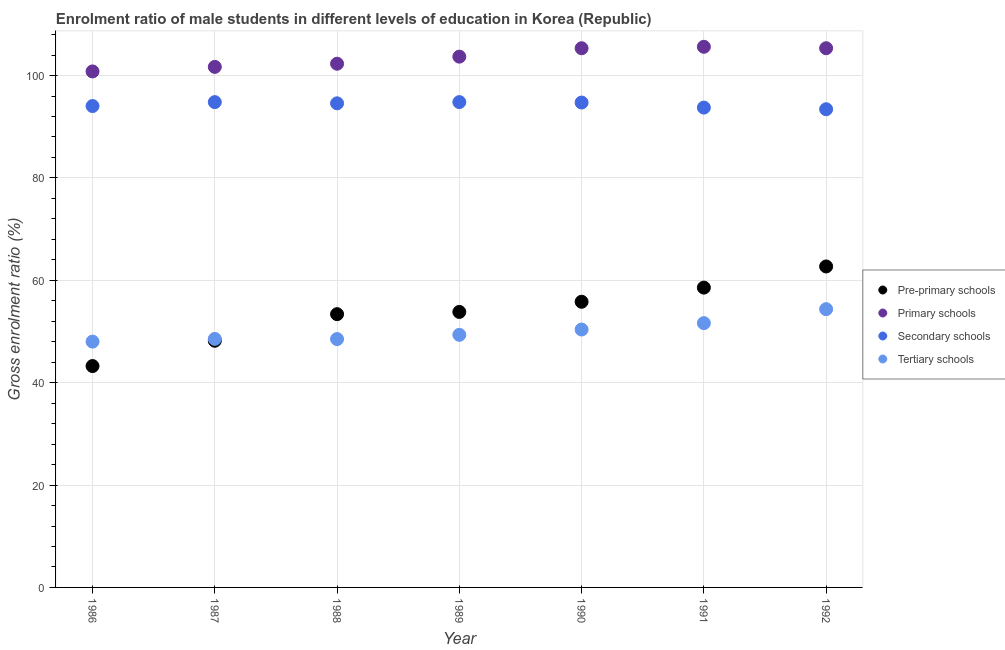How many different coloured dotlines are there?
Give a very brief answer. 4. What is the gross enrolment ratio(female) in tertiary schools in 1988?
Give a very brief answer. 48.52. Across all years, what is the maximum gross enrolment ratio(female) in pre-primary schools?
Your response must be concise. 62.71. Across all years, what is the minimum gross enrolment ratio(female) in secondary schools?
Ensure brevity in your answer.  93.42. In which year was the gross enrolment ratio(female) in tertiary schools maximum?
Offer a very short reply. 1992. What is the total gross enrolment ratio(female) in primary schools in the graph?
Your response must be concise. 724.82. What is the difference between the gross enrolment ratio(female) in tertiary schools in 1986 and that in 1992?
Your answer should be very brief. -6.34. What is the difference between the gross enrolment ratio(female) in pre-primary schools in 1990 and the gross enrolment ratio(female) in tertiary schools in 1992?
Provide a succinct answer. 1.45. What is the average gross enrolment ratio(female) in primary schools per year?
Make the answer very short. 103.55. In the year 1987, what is the difference between the gross enrolment ratio(female) in primary schools and gross enrolment ratio(female) in tertiary schools?
Keep it short and to the point. 53.14. What is the ratio of the gross enrolment ratio(female) in tertiary schools in 1988 to that in 1989?
Your answer should be very brief. 0.98. Is the gross enrolment ratio(female) in secondary schools in 1987 less than that in 1990?
Offer a terse response. No. Is the difference between the gross enrolment ratio(female) in secondary schools in 1988 and 1992 greater than the difference between the gross enrolment ratio(female) in pre-primary schools in 1988 and 1992?
Ensure brevity in your answer.  Yes. What is the difference between the highest and the second highest gross enrolment ratio(female) in pre-primary schools?
Offer a terse response. 4.13. What is the difference between the highest and the lowest gross enrolment ratio(female) in secondary schools?
Offer a terse response. 1.4. Is the sum of the gross enrolment ratio(female) in primary schools in 1986 and 1988 greater than the maximum gross enrolment ratio(female) in secondary schools across all years?
Offer a terse response. Yes. Is it the case that in every year, the sum of the gross enrolment ratio(female) in pre-primary schools and gross enrolment ratio(female) in primary schools is greater than the gross enrolment ratio(female) in secondary schools?
Offer a very short reply. Yes. Does the gross enrolment ratio(female) in pre-primary schools monotonically increase over the years?
Keep it short and to the point. Yes. Is the gross enrolment ratio(female) in primary schools strictly greater than the gross enrolment ratio(female) in pre-primary schools over the years?
Make the answer very short. Yes. Is the gross enrolment ratio(female) in primary schools strictly less than the gross enrolment ratio(female) in tertiary schools over the years?
Make the answer very short. No. What is the difference between two consecutive major ticks on the Y-axis?
Give a very brief answer. 20. Are the values on the major ticks of Y-axis written in scientific E-notation?
Provide a succinct answer. No. Does the graph contain grids?
Offer a terse response. Yes. Where does the legend appear in the graph?
Ensure brevity in your answer.  Center right. What is the title of the graph?
Your answer should be very brief. Enrolment ratio of male students in different levels of education in Korea (Republic). What is the label or title of the X-axis?
Your answer should be very brief. Year. What is the label or title of the Y-axis?
Offer a very short reply. Gross enrolment ratio (%). What is the Gross enrolment ratio (%) in Pre-primary schools in 1986?
Keep it short and to the point. 43.25. What is the Gross enrolment ratio (%) in Primary schools in 1986?
Provide a short and direct response. 100.81. What is the Gross enrolment ratio (%) in Secondary schools in 1986?
Your answer should be compact. 94.04. What is the Gross enrolment ratio (%) in Tertiary schools in 1986?
Your response must be concise. 48.02. What is the Gross enrolment ratio (%) in Pre-primary schools in 1987?
Your response must be concise. 48.19. What is the Gross enrolment ratio (%) of Primary schools in 1987?
Give a very brief answer. 101.69. What is the Gross enrolment ratio (%) in Secondary schools in 1987?
Give a very brief answer. 94.81. What is the Gross enrolment ratio (%) of Tertiary schools in 1987?
Offer a very short reply. 48.55. What is the Gross enrolment ratio (%) of Pre-primary schools in 1988?
Make the answer very short. 53.39. What is the Gross enrolment ratio (%) in Primary schools in 1988?
Provide a short and direct response. 102.32. What is the Gross enrolment ratio (%) of Secondary schools in 1988?
Offer a terse response. 94.58. What is the Gross enrolment ratio (%) in Tertiary schools in 1988?
Offer a very short reply. 48.52. What is the Gross enrolment ratio (%) of Pre-primary schools in 1989?
Your answer should be very brief. 53.82. What is the Gross enrolment ratio (%) in Primary schools in 1989?
Keep it short and to the point. 103.7. What is the Gross enrolment ratio (%) of Secondary schools in 1989?
Provide a short and direct response. 94.82. What is the Gross enrolment ratio (%) of Tertiary schools in 1989?
Provide a succinct answer. 49.35. What is the Gross enrolment ratio (%) of Pre-primary schools in 1990?
Your response must be concise. 55.81. What is the Gross enrolment ratio (%) in Primary schools in 1990?
Provide a succinct answer. 105.34. What is the Gross enrolment ratio (%) of Secondary schools in 1990?
Offer a very short reply. 94.73. What is the Gross enrolment ratio (%) of Tertiary schools in 1990?
Keep it short and to the point. 50.39. What is the Gross enrolment ratio (%) in Pre-primary schools in 1991?
Keep it short and to the point. 58.58. What is the Gross enrolment ratio (%) in Primary schools in 1991?
Keep it short and to the point. 105.62. What is the Gross enrolment ratio (%) in Secondary schools in 1991?
Provide a succinct answer. 93.74. What is the Gross enrolment ratio (%) of Tertiary schools in 1991?
Your answer should be compact. 51.63. What is the Gross enrolment ratio (%) of Pre-primary schools in 1992?
Give a very brief answer. 62.71. What is the Gross enrolment ratio (%) of Primary schools in 1992?
Ensure brevity in your answer.  105.34. What is the Gross enrolment ratio (%) in Secondary schools in 1992?
Provide a short and direct response. 93.42. What is the Gross enrolment ratio (%) of Tertiary schools in 1992?
Give a very brief answer. 54.36. Across all years, what is the maximum Gross enrolment ratio (%) in Pre-primary schools?
Your answer should be compact. 62.71. Across all years, what is the maximum Gross enrolment ratio (%) of Primary schools?
Ensure brevity in your answer.  105.62. Across all years, what is the maximum Gross enrolment ratio (%) of Secondary schools?
Offer a terse response. 94.82. Across all years, what is the maximum Gross enrolment ratio (%) in Tertiary schools?
Your response must be concise. 54.36. Across all years, what is the minimum Gross enrolment ratio (%) in Pre-primary schools?
Your answer should be very brief. 43.25. Across all years, what is the minimum Gross enrolment ratio (%) of Primary schools?
Ensure brevity in your answer.  100.81. Across all years, what is the minimum Gross enrolment ratio (%) of Secondary schools?
Your answer should be very brief. 93.42. Across all years, what is the minimum Gross enrolment ratio (%) in Tertiary schools?
Your answer should be very brief. 48.02. What is the total Gross enrolment ratio (%) in Pre-primary schools in the graph?
Provide a short and direct response. 375.74. What is the total Gross enrolment ratio (%) in Primary schools in the graph?
Offer a very short reply. 724.82. What is the total Gross enrolment ratio (%) in Secondary schools in the graph?
Offer a very short reply. 660.15. What is the total Gross enrolment ratio (%) of Tertiary schools in the graph?
Offer a terse response. 350.82. What is the difference between the Gross enrolment ratio (%) of Pre-primary schools in 1986 and that in 1987?
Your answer should be very brief. -4.95. What is the difference between the Gross enrolment ratio (%) of Primary schools in 1986 and that in 1987?
Your answer should be compact. -0.89. What is the difference between the Gross enrolment ratio (%) in Secondary schools in 1986 and that in 1987?
Provide a short and direct response. -0.77. What is the difference between the Gross enrolment ratio (%) in Tertiary schools in 1986 and that in 1987?
Your answer should be compact. -0.53. What is the difference between the Gross enrolment ratio (%) of Pre-primary schools in 1986 and that in 1988?
Your response must be concise. -10.14. What is the difference between the Gross enrolment ratio (%) of Primary schools in 1986 and that in 1988?
Keep it short and to the point. -1.51. What is the difference between the Gross enrolment ratio (%) in Secondary schools in 1986 and that in 1988?
Provide a short and direct response. -0.53. What is the difference between the Gross enrolment ratio (%) in Tertiary schools in 1986 and that in 1988?
Provide a short and direct response. -0.5. What is the difference between the Gross enrolment ratio (%) of Pre-primary schools in 1986 and that in 1989?
Ensure brevity in your answer.  -10.58. What is the difference between the Gross enrolment ratio (%) in Primary schools in 1986 and that in 1989?
Provide a succinct answer. -2.89. What is the difference between the Gross enrolment ratio (%) in Secondary schools in 1986 and that in 1989?
Provide a short and direct response. -0.77. What is the difference between the Gross enrolment ratio (%) of Tertiary schools in 1986 and that in 1989?
Provide a short and direct response. -1.33. What is the difference between the Gross enrolment ratio (%) of Pre-primary schools in 1986 and that in 1990?
Your answer should be compact. -12.56. What is the difference between the Gross enrolment ratio (%) of Primary schools in 1986 and that in 1990?
Your answer should be compact. -4.53. What is the difference between the Gross enrolment ratio (%) in Secondary schools in 1986 and that in 1990?
Give a very brief answer. -0.69. What is the difference between the Gross enrolment ratio (%) in Tertiary schools in 1986 and that in 1990?
Offer a very short reply. -2.37. What is the difference between the Gross enrolment ratio (%) in Pre-primary schools in 1986 and that in 1991?
Keep it short and to the point. -15.33. What is the difference between the Gross enrolment ratio (%) of Primary schools in 1986 and that in 1991?
Your answer should be compact. -4.81. What is the difference between the Gross enrolment ratio (%) of Secondary schools in 1986 and that in 1991?
Ensure brevity in your answer.  0.3. What is the difference between the Gross enrolment ratio (%) of Tertiary schools in 1986 and that in 1991?
Your answer should be compact. -3.61. What is the difference between the Gross enrolment ratio (%) in Pre-primary schools in 1986 and that in 1992?
Ensure brevity in your answer.  -19.46. What is the difference between the Gross enrolment ratio (%) in Primary schools in 1986 and that in 1992?
Keep it short and to the point. -4.53. What is the difference between the Gross enrolment ratio (%) in Secondary schools in 1986 and that in 1992?
Offer a very short reply. 0.62. What is the difference between the Gross enrolment ratio (%) of Tertiary schools in 1986 and that in 1992?
Your answer should be very brief. -6.34. What is the difference between the Gross enrolment ratio (%) in Pre-primary schools in 1987 and that in 1988?
Your answer should be compact. -5.19. What is the difference between the Gross enrolment ratio (%) of Primary schools in 1987 and that in 1988?
Keep it short and to the point. -0.62. What is the difference between the Gross enrolment ratio (%) of Secondary schools in 1987 and that in 1988?
Provide a short and direct response. 0.24. What is the difference between the Gross enrolment ratio (%) of Tertiary schools in 1987 and that in 1988?
Give a very brief answer. 0.03. What is the difference between the Gross enrolment ratio (%) in Pre-primary schools in 1987 and that in 1989?
Give a very brief answer. -5.63. What is the difference between the Gross enrolment ratio (%) in Primary schools in 1987 and that in 1989?
Offer a very short reply. -2. What is the difference between the Gross enrolment ratio (%) in Secondary schools in 1987 and that in 1989?
Your answer should be very brief. -0. What is the difference between the Gross enrolment ratio (%) in Tertiary schools in 1987 and that in 1989?
Your answer should be compact. -0.8. What is the difference between the Gross enrolment ratio (%) of Pre-primary schools in 1987 and that in 1990?
Your answer should be compact. -7.61. What is the difference between the Gross enrolment ratio (%) of Primary schools in 1987 and that in 1990?
Keep it short and to the point. -3.64. What is the difference between the Gross enrolment ratio (%) of Secondary schools in 1987 and that in 1990?
Your answer should be compact. 0.08. What is the difference between the Gross enrolment ratio (%) of Tertiary schools in 1987 and that in 1990?
Keep it short and to the point. -1.83. What is the difference between the Gross enrolment ratio (%) of Pre-primary schools in 1987 and that in 1991?
Provide a short and direct response. -10.38. What is the difference between the Gross enrolment ratio (%) of Primary schools in 1987 and that in 1991?
Ensure brevity in your answer.  -3.93. What is the difference between the Gross enrolment ratio (%) of Secondary schools in 1987 and that in 1991?
Keep it short and to the point. 1.07. What is the difference between the Gross enrolment ratio (%) in Tertiary schools in 1987 and that in 1991?
Provide a succinct answer. -3.08. What is the difference between the Gross enrolment ratio (%) in Pre-primary schools in 1987 and that in 1992?
Make the answer very short. -14.51. What is the difference between the Gross enrolment ratio (%) of Primary schools in 1987 and that in 1992?
Give a very brief answer. -3.65. What is the difference between the Gross enrolment ratio (%) of Secondary schools in 1987 and that in 1992?
Provide a succinct answer. 1.39. What is the difference between the Gross enrolment ratio (%) in Tertiary schools in 1987 and that in 1992?
Ensure brevity in your answer.  -5.81. What is the difference between the Gross enrolment ratio (%) of Pre-primary schools in 1988 and that in 1989?
Your response must be concise. -0.44. What is the difference between the Gross enrolment ratio (%) of Primary schools in 1988 and that in 1989?
Give a very brief answer. -1.38. What is the difference between the Gross enrolment ratio (%) in Secondary schools in 1988 and that in 1989?
Provide a short and direct response. -0.24. What is the difference between the Gross enrolment ratio (%) in Tertiary schools in 1988 and that in 1989?
Your response must be concise. -0.83. What is the difference between the Gross enrolment ratio (%) of Pre-primary schools in 1988 and that in 1990?
Provide a succinct answer. -2.42. What is the difference between the Gross enrolment ratio (%) in Primary schools in 1988 and that in 1990?
Give a very brief answer. -3.02. What is the difference between the Gross enrolment ratio (%) of Secondary schools in 1988 and that in 1990?
Make the answer very short. -0.16. What is the difference between the Gross enrolment ratio (%) of Tertiary schools in 1988 and that in 1990?
Ensure brevity in your answer.  -1.87. What is the difference between the Gross enrolment ratio (%) in Pre-primary schools in 1988 and that in 1991?
Offer a very short reply. -5.19. What is the difference between the Gross enrolment ratio (%) in Primary schools in 1988 and that in 1991?
Provide a succinct answer. -3.31. What is the difference between the Gross enrolment ratio (%) of Secondary schools in 1988 and that in 1991?
Provide a short and direct response. 0.83. What is the difference between the Gross enrolment ratio (%) in Tertiary schools in 1988 and that in 1991?
Your answer should be very brief. -3.12. What is the difference between the Gross enrolment ratio (%) of Pre-primary schools in 1988 and that in 1992?
Your answer should be compact. -9.32. What is the difference between the Gross enrolment ratio (%) in Primary schools in 1988 and that in 1992?
Your answer should be compact. -3.03. What is the difference between the Gross enrolment ratio (%) of Secondary schools in 1988 and that in 1992?
Ensure brevity in your answer.  1.15. What is the difference between the Gross enrolment ratio (%) of Tertiary schools in 1988 and that in 1992?
Your answer should be very brief. -5.84. What is the difference between the Gross enrolment ratio (%) of Pre-primary schools in 1989 and that in 1990?
Offer a very short reply. -1.98. What is the difference between the Gross enrolment ratio (%) of Primary schools in 1989 and that in 1990?
Your answer should be compact. -1.64. What is the difference between the Gross enrolment ratio (%) of Secondary schools in 1989 and that in 1990?
Your response must be concise. 0.08. What is the difference between the Gross enrolment ratio (%) of Tertiary schools in 1989 and that in 1990?
Make the answer very short. -1.04. What is the difference between the Gross enrolment ratio (%) in Pre-primary schools in 1989 and that in 1991?
Provide a short and direct response. -4.75. What is the difference between the Gross enrolment ratio (%) of Primary schools in 1989 and that in 1991?
Offer a terse response. -1.93. What is the difference between the Gross enrolment ratio (%) of Secondary schools in 1989 and that in 1991?
Give a very brief answer. 1.07. What is the difference between the Gross enrolment ratio (%) in Tertiary schools in 1989 and that in 1991?
Offer a very short reply. -2.29. What is the difference between the Gross enrolment ratio (%) in Pre-primary schools in 1989 and that in 1992?
Provide a short and direct response. -8.88. What is the difference between the Gross enrolment ratio (%) of Primary schools in 1989 and that in 1992?
Your answer should be compact. -1.65. What is the difference between the Gross enrolment ratio (%) of Secondary schools in 1989 and that in 1992?
Your answer should be compact. 1.4. What is the difference between the Gross enrolment ratio (%) in Tertiary schools in 1989 and that in 1992?
Provide a succinct answer. -5.01. What is the difference between the Gross enrolment ratio (%) in Pre-primary schools in 1990 and that in 1991?
Your answer should be compact. -2.77. What is the difference between the Gross enrolment ratio (%) in Primary schools in 1990 and that in 1991?
Ensure brevity in your answer.  -0.28. What is the difference between the Gross enrolment ratio (%) of Secondary schools in 1990 and that in 1991?
Your answer should be compact. 0.99. What is the difference between the Gross enrolment ratio (%) in Tertiary schools in 1990 and that in 1991?
Give a very brief answer. -1.25. What is the difference between the Gross enrolment ratio (%) in Pre-primary schools in 1990 and that in 1992?
Your answer should be compact. -6.9. What is the difference between the Gross enrolment ratio (%) in Primary schools in 1990 and that in 1992?
Your answer should be compact. -0. What is the difference between the Gross enrolment ratio (%) in Secondary schools in 1990 and that in 1992?
Your answer should be very brief. 1.31. What is the difference between the Gross enrolment ratio (%) of Tertiary schools in 1990 and that in 1992?
Your answer should be very brief. -3.98. What is the difference between the Gross enrolment ratio (%) in Pre-primary schools in 1991 and that in 1992?
Your answer should be very brief. -4.13. What is the difference between the Gross enrolment ratio (%) of Primary schools in 1991 and that in 1992?
Ensure brevity in your answer.  0.28. What is the difference between the Gross enrolment ratio (%) in Secondary schools in 1991 and that in 1992?
Make the answer very short. 0.32. What is the difference between the Gross enrolment ratio (%) in Tertiary schools in 1991 and that in 1992?
Your answer should be very brief. -2.73. What is the difference between the Gross enrolment ratio (%) in Pre-primary schools in 1986 and the Gross enrolment ratio (%) in Primary schools in 1987?
Your response must be concise. -58.45. What is the difference between the Gross enrolment ratio (%) in Pre-primary schools in 1986 and the Gross enrolment ratio (%) in Secondary schools in 1987?
Your answer should be very brief. -51.57. What is the difference between the Gross enrolment ratio (%) in Pre-primary schools in 1986 and the Gross enrolment ratio (%) in Tertiary schools in 1987?
Provide a short and direct response. -5.31. What is the difference between the Gross enrolment ratio (%) in Primary schools in 1986 and the Gross enrolment ratio (%) in Secondary schools in 1987?
Your answer should be very brief. 6. What is the difference between the Gross enrolment ratio (%) of Primary schools in 1986 and the Gross enrolment ratio (%) of Tertiary schools in 1987?
Offer a terse response. 52.26. What is the difference between the Gross enrolment ratio (%) of Secondary schools in 1986 and the Gross enrolment ratio (%) of Tertiary schools in 1987?
Make the answer very short. 45.49. What is the difference between the Gross enrolment ratio (%) of Pre-primary schools in 1986 and the Gross enrolment ratio (%) of Primary schools in 1988?
Offer a terse response. -59.07. What is the difference between the Gross enrolment ratio (%) of Pre-primary schools in 1986 and the Gross enrolment ratio (%) of Secondary schools in 1988?
Make the answer very short. -51.33. What is the difference between the Gross enrolment ratio (%) of Pre-primary schools in 1986 and the Gross enrolment ratio (%) of Tertiary schools in 1988?
Ensure brevity in your answer.  -5.27. What is the difference between the Gross enrolment ratio (%) in Primary schools in 1986 and the Gross enrolment ratio (%) in Secondary schools in 1988?
Give a very brief answer. 6.23. What is the difference between the Gross enrolment ratio (%) in Primary schools in 1986 and the Gross enrolment ratio (%) in Tertiary schools in 1988?
Provide a succinct answer. 52.29. What is the difference between the Gross enrolment ratio (%) in Secondary schools in 1986 and the Gross enrolment ratio (%) in Tertiary schools in 1988?
Make the answer very short. 45.53. What is the difference between the Gross enrolment ratio (%) of Pre-primary schools in 1986 and the Gross enrolment ratio (%) of Primary schools in 1989?
Your response must be concise. -60.45. What is the difference between the Gross enrolment ratio (%) of Pre-primary schools in 1986 and the Gross enrolment ratio (%) of Secondary schools in 1989?
Provide a succinct answer. -51.57. What is the difference between the Gross enrolment ratio (%) in Pre-primary schools in 1986 and the Gross enrolment ratio (%) in Tertiary schools in 1989?
Provide a succinct answer. -6.1. What is the difference between the Gross enrolment ratio (%) in Primary schools in 1986 and the Gross enrolment ratio (%) in Secondary schools in 1989?
Your answer should be very brief. 5.99. What is the difference between the Gross enrolment ratio (%) in Primary schools in 1986 and the Gross enrolment ratio (%) in Tertiary schools in 1989?
Provide a short and direct response. 51.46. What is the difference between the Gross enrolment ratio (%) of Secondary schools in 1986 and the Gross enrolment ratio (%) of Tertiary schools in 1989?
Offer a terse response. 44.7. What is the difference between the Gross enrolment ratio (%) in Pre-primary schools in 1986 and the Gross enrolment ratio (%) in Primary schools in 1990?
Provide a succinct answer. -62.09. What is the difference between the Gross enrolment ratio (%) in Pre-primary schools in 1986 and the Gross enrolment ratio (%) in Secondary schools in 1990?
Your response must be concise. -51.48. What is the difference between the Gross enrolment ratio (%) of Pre-primary schools in 1986 and the Gross enrolment ratio (%) of Tertiary schools in 1990?
Your answer should be compact. -7.14. What is the difference between the Gross enrolment ratio (%) of Primary schools in 1986 and the Gross enrolment ratio (%) of Secondary schools in 1990?
Keep it short and to the point. 6.08. What is the difference between the Gross enrolment ratio (%) in Primary schools in 1986 and the Gross enrolment ratio (%) in Tertiary schools in 1990?
Offer a terse response. 50.42. What is the difference between the Gross enrolment ratio (%) of Secondary schools in 1986 and the Gross enrolment ratio (%) of Tertiary schools in 1990?
Keep it short and to the point. 43.66. What is the difference between the Gross enrolment ratio (%) of Pre-primary schools in 1986 and the Gross enrolment ratio (%) of Primary schools in 1991?
Offer a terse response. -62.38. What is the difference between the Gross enrolment ratio (%) of Pre-primary schools in 1986 and the Gross enrolment ratio (%) of Secondary schools in 1991?
Give a very brief answer. -50.5. What is the difference between the Gross enrolment ratio (%) in Pre-primary schools in 1986 and the Gross enrolment ratio (%) in Tertiary schools in 1991?
Your response must be concise. -8.39. What is the difference between the Gross enrolment ratio (%) in Primary schools in 1986 and the Gross enrolment ratio (%) in Secondary schools in 1991?
Give a very brief answer. 7.06. What is the difference between the Gross enrolment ratio (%) in Primary schools in 1986 and the Gross enrolment ratio (%) in Tertiary schools in 1991?
Provide a short and direct response. 49.18. What is the difference between the Gross enrolment ratio (%) in Secondary schools in 1986 and the Gross enrolment ratio (%) in Tertiary schools in 1991?
Provide a short and direct response. 42.41. What is the difference between the Gross enrolment ratio (%) of Pre-primary schools in 1986 and the Gross enrolment ratio (%) of Primary schools in 1992?
Your answer should be very brief. -62.1. What is the difference between the Gross enrolment ratio (%) in Pre-primary schools in 1986 and the Gross enrolment ratio (%) in Secondary schools in 1992?
Provide a succinct answer. -50.17. What is the difference between the Gross enrolment ratio (%) of Pre-primary schools in 1986 and the Gross enrolment ratio (%) of Tertiary schools in 1992?
Your answer should be very brief. -11.12. What is the difference between the Gross enrolment ratio (%) in Primary schools in 1986 and the Gross enrolment ratio (%) in Secondary schools in 1992?
Ensure brevity in your answer.  7.39. What is the difference between the Gross enrolment ratio (%) of Primary schools in 1986 and the Gross enrolment ratio (%) of Tertiary schools in 1992?
Your answer should be very brief. 46.45. What is the difference between the Gross enrolment ratio (%) in Secondary schools in 1986 and the Gross enrolment ratio (%) in Tertiary schools in 1992?
Offer a terse response. 39.68. What is the difference between the Gross enrolment ratio (%) in Pre-primary schools in 1987 and the Gross enrolment ratio (%) in Primary schools in 1988?
Your response must be concise. -54.12. What is the difference between the Gross enrolment ratio (%) of Pre-primary schools in 1987 and the Gross enrolment ratio (%) of Secondary schools in 1988?
Offer a terse response. -46.38. What is the difference between the Gross enrolment ratio (%) of Pre-primary schools in 1987 and the Gross enrolment ratio (%) of Tertiary schools in 1988?
Your answer should be very brief. -0.32. What is the difference between the Gross enrolment ratio (%) of Primary schools in 1987 and the Gross enrolment ratio (%) of Secondary schools in 1988?
Provide a succinct answer. 7.12. What is the difference between the Gross enrolment ratio (%) in Primary schools in 1987 and the Gross enrolment ratio (%) in Tertiary schools in 1988?
Offer a very short reply. 53.18. What is the difference between the Gross enrolment ratio (%) in Secondary schools in 1987 and the Gross enrolment ratio (%) in Tertiary schools in 1988?
Make the answer very short. 46.29. What is the difference between the Gross enrolment ratio (%) in Pre-primary schools in 1987 and the Gross enrolment ratio (%) in Primary schools in 1989?
Make the answer very short. -55.5. What is the difference between the Gross enrolment ratio (%) in Pre-primary schools in 1987 and the Gross enrolment ratio (%) in Secondary schools in 1989?
Your answer should be very brief. -46.62. What is the difference between the Gross enrolment ratio (%) in Pre-primary schools in 1987 and the Gross enrolment ratio (%) in Tertiary schools in 1989?
Your answer should be very brief. -1.15. What is the difference between the Gross enrolment ratio (%) in Primary schools in 1987 and the Gross enrolment ratio (%) in Secondary schools in 1989?
Make the answer very short. 6.88. What is the difference between the Gross enrolment ratio (%) in Primary schools in 1987 and the Gross enrolment ratio (%) in Tertiary schools in 1989?
Provide a succinct answer. 52.35. What is the difference between the Gross enrolment ratio (%) of Secondary schools in 1987 and the Gross enrolment ratio (%) of Tertiary schools in 1989?
Your answer should be compact. 45.46. What is the difference between the Gross enrolment ratio (%) of Pre-primary schools in 1987 and the Gross enrolment ratio (%) of Primary schools in 1990?
Your answer should be very brief. -57.14. What is the difference between the Gross enrolment ratio (%) of Pre-primary schools in 1987 and the Gross enrolment ratio (%) of Secondary schools in 1990?
Your answer should be very brief. -46.54. What is the difference between the Gross enrolment ratio (%) of Pre-primary schools in 1987 and the Gross enrolment ratio (%) of Tertiary schools in 1990?
Ensure brevity in your answer.  -2.19. What is the difference between the Gross enrolment ratio (%) in Primary schools in 1987 and the Gross enrolment ratio (%) in Secondary schools in 1990?
Offer a terse response. 6.96. What is the difference between the Gross enrolment ratio (%) of Primary schools in 1987 and the Gross enrolment ratio (%) of Tertiary schools in 1990?
Your response must be concise. 51.31. What is the difference between the Gross enrolment ratio (%) of Secondary schools in 1987 and the Gross enrolment ratio (%) of Tertiary schools in 1990?
Offer a very short reply. 44.43. What is the difference between the Gross enrolment ratio (%) in Pre-primary schools in 1987 and the Gross enrolment ratio (%) in Primary schools in 1991?
Provide a short and direct response. -57.43. What is the difference between the Gross enrolment ratio (%) in Pre-primary schools in 1987 and the Gross enrolment ratio (%) in Secondary schools in 1991?
Give a very brief answer. -45.55. What is the difference between the Gross enrolment ratio (%) in Pre-primary schools in 1987 and the Gross enrolment ratio (%) in Tertiary schools in 1991?
Offer a terse response. -3.44. What is the difference between the Gross enrolment ratio (%) in Primary schools in 1987 and the Gross enrolment ratio (%) in Secondary schools in 1991?
Provide a succinct answer. 7.95. What is the difference between the Gross enrolment ratio (%) in Primary schools in 1987 and the Gross enrolment ratio (%) in Tertiary schools in 1991?
Provide a succinct answer. 50.06. What is the difference between the Gross enrolment ratio (%) in Secondary schools in 1987 and the Gross enrolment ratio (%) in Tertiary schools in 1991?
Your response must be concise. 43.18. What is the difference between the Gross enrolment ratio (%) of Pre-primary schools in 1987 and the Gross enrolment ratio (%) of Primary schools in 1992?
Keep it short and to the point. -57.15. What is the difference between the Gross enrolment ratio (%) in Pre-primary schools in 1987 and the Gross enrolment ratio (%) in Secondary schools in 1992?
Your response must be concise. -45.23. What is the difference between the Gross enrolment ratio (%) of Pre-primary schools in 1987 and the Gross enrolment ratio (%) of Tertiary schools in 1992?
Your answer should be very brief. -6.17. What is the difference between the Gross enrolment ratio (%) of Primary schools in 1987 and the Gross enrolment ratio (%) of Secondary schools in 1992?
Your response must be concise. 8.27. What is the difference between the Gross enrolment ratio (%) in Primary schools in 1987 and the Gross enrolment ratio (%) in Tertiary schools in 1992?
Ensure brevity in your answer.  47.33. What is the difference between the Gross enrolment ratio (%) of Secondary schools in 1987 and the Gross enrolment ratio (%) of Tertiary schools in 1992?
Give a very brief answer. 40.45. What is the difference between the Gross enrolment ratio (%) of Pre-primary schools in 1988 and the Gross enrolment ratio (%) of Primary schools in 1989?
Your response must be concise. -50.31. What is the difference between the Gross enrolment ratio (%) of Pre-primary schools in 1988 and the Gross enrolment ratio (%) of Secondary schools in 1989?
Provide a short and direct response. -41.43. What is the difference between the Gross enrolment ratio (%) of Pre-primary schools in 1988 and the Gross enrolment ratio (%) of Tertiary schools in 1989?
Provide a short and direct response. 4.04. What is the difference between the Gross enrolment ratio (%) of Primary schools in 1988 and the Gross enrolment ratio (%) of Secondary schools in 1989?
Your answer should be very brief. 7.5. What is the difference between the Gross enrolment ratio (%) of Primary schools in 1988 and the Gross enrolment ratio (%) of Tertiary schools in 1989?
Keep it short and to the point. 52.97. What is the difference between the Gross enrolment ratio (%) in Secondary schools in 1988 and the Gross enrolment ratio (%) in Tertiary schools in 1989?
Give a very brief answer. 45.23. What is the difference between the Gross enrolment ratio (%) in Pre-primary schools in 1988 and the Gross enrolment ratio (%) in Primary schools in 1990?
Offer a very short reply. -51.95. What is the difference between the Gross enrolment ratio (%) of Pre-primary schools in 1988 and the Gross enrolment ratio (%) of Secondary schools in 1990?
Provide a short and direct response. -41.35. What is the difference between the Gross enrolment ratio (%) of Pre-primary schools in 1988 and the Gross enrolment ratio (%) of Tertiary schools in 1990?
Provide a succinct answer. 3. What is the difference between the Gross enrolment ratio (%) in Primary schools in 1988 and the Gross enrolment ratio (%) in Secondary schools in 1990?
Keep it short and to the point. 7.58. What is the difference between the Gross enrolment ratio (%) of Primary schools in 1988 and the Gross enrolment ratio (%) of Tertiary schools in 1990?
Offer a very short reply. 51.93. What is the difference between the Gross enrolment ratio (%) in Secondary schools in 1988 and the Gross enrolment ratio (%) in Tertiary schools in 1990?
Your answer should be very brief. 44.19. What is the difference between the Gross enrolment ratio (%) in Pre-primary schools in 1988 and the Gross enrolment ratio (%) in Primary schools in 1991?
Your answer should be compact. -52.24. What is the difference between the Gross enrolment ratio (%) of Pre-primary schools in 1988 and the Gross enrolment ratio (%) of Secondary schools in 1991?
Provide a succinct answer. -40.36. What is the difference between the Gross enrolment ratio (%) in Pre-primary schools in 1988 and the Gross enrolment ratio (%) in Tertiary schools in 1991?
Provide a succinct answer. 1.75. What is the difference between the Gross enrolment ratio (%) in Primary schools in 1988 and the Gross enrolment ratio (%) in Secondary schools in 1991?
Make the answer very short. 8.57. What is the difference between the Gross enrolment ratio (%) of Primary schools in 1988 and the Gross enrolment ratio (%) of Tertiary schools in 1991?
Ensure brevity in your answer.  50.68. What is the difference between the Gross enrolment ratio (%) in Secondary schools in 1988 and the Gross enrolment ratio (%) in Tertiary schools in 1991?
Your response must be concise. 42.94. What is the difference between the Gross enrolment ratio (%) in Pre-primary schools in 1988 and the Gross enrolment ratio (%) in Primary schools in 1992?
Offer a very short reply. -51.96. What is the difference between the Gross enrolment ratio (%) in Pre-primary schools in 1988 and the Gross enrolment ratio (%) in Secondary schools in 1992?
Make the answer very short. -40.04. What is the difference between the Gross enrolment ratio (%) in Pre-primary schools in 1988 and the Gross enrolment ratio (%) in Tertiary schools in 1992?
Give a very brief answer. -0.98. What is the difference between the Gross enrolment ratio (%) of Primary schools in 1988 and the Gross enrolment ratio (%) of Secondary schools in 1992?
Provide a short and direct response. 8.89. What is the difference between the Gross enrolment ratio (%) in Primary schools in 1988 and the Gross enrolment ratio (%) in Tertiary schools in 1992?
Offer a terse response. 47.95. What is the difference between the Gross enrolment ratio (%) of Secondary schools in 1988 and the Gross enrolment ratio (%) of Tertiary schools in 1992?
Provide a succinct answer. 40.21. What is the difference between the Gross enrolment ratio (%) in Pre-primary schools in 1989 and the Gross enrolment ratio (%) in Primary schools in 1990?
Your answer should be very brief. -51.51. What is the difference between the Gross enrolment ratio (%) in Pre-primary schools in 1989 and the Gross enrolment ratio (%) in Secondary schools in 1990?
Offer a terse response. -40.91. What is the difference between the Gross enrolment ratio (%) in Pre-primary schools in 1989 and the Gross enrolment ratio (%) in Tertiary schools in 1990?
Give a very brief answer. 3.44. What is the difference between the Gross enrolment ratio (%) in Primary schools in 1989 and the Gross enrolment ratio (%) in Secondary schools in 1990?
Provide a succinct answer. 8.96. What is the difference between the Gross enrolment ratio (%) of Primary schools in 1989 and the Gross enrolment ratio (%) of Tertiary schools in 1990?
Ensure brevity in your answer.  53.31. What is the difference between the Gross enrolment ratio (%) in Secondary schools in 1989 and the Gross enrolment ratio (%) in Tertiary schools in 1990?
Offer a terse response. 44.43. What is the difference between the Gross enrolment ratio (%) of Pre-primary schools in 1989 and the Gross enrolment ratio (%) of Primary schools in 1991?
Keep it short and to the point. -51.8. What is the difference between the Gross enrolment ratio (%) in Pre-primary schools in 1989 and the Gross enrolment ratio (%) in Secondary schools in 1991?
Make the answer very short. -39.92. What is the difference between the Gross enrolment ratio (%) of Pre-primary schools in 1989 and the Gross enrolment ratio (%) of Tertiary schools in 1991?
Your answer should be very brief. 2.19. What is the difference between the Gross enrolment ratio (%) of Primary schools in 1989 and the Gross enrolment ratio (%) of Secondary schools in 1991?
Give a very brief answer. 9.95. What is the difference between the Gross enrolment ratio (%) of Primary schools in 1989 and the Gross enrolment ratio (%) of Tertiary schools in 1991?
Offer a very short reply. 52.06. What is the difference between the Gross enrolment ratio (%) of Secondary schools in 1989 and the Gross enrolment ratio (%) of Tertiary schools in 1991?
Your response must be concise. 43.18. What is the difference between the Gross enrolment ratio (%) of Pre-primary schools in 1989 and the Gross enrolment ratio (%) of Primary schools in 1992?
Provide a short and direct response. -51.52. What is the difference between the Gross enrolment ratio (%) of Pre-primary schools in 1989 and the Gross enrolment ratio (%) of Secondary schools in 1992?
Offer a very short reply. -39.6. What is the difference between the Gross enrolment ratio (%) in Pre-primary schools in 1989 and the Gross enrolment ratio (%) in Tertiary schools in 1992?
Give a very brief answer. -0.54. What is the difference between the Gross enrolment ratio (%) in Primary schools in 1989 and the Gross enrolment ratio (%) in Secondary schools in 1992?
Provide a succinct answer. 10.27. What is the difference between the Gross enrolment ratio (%) in Primary schools in 1989 and the Gross enrolment ratio (%) in Tertiary schools in 1992?
Provide a short and direct response. 49.33. What is the difference between the Gross enrolment ratio (%) in Secondary schools in 1989 and the Gross enrolment ratio (%) in Tertiary schools in 1992?
Give a very brief answer. 40.45. What is the difference between the Gross enrolment ratio (%) of Pre-primary schools in 1990 and the Gross enrolment ratio (%) of Primary schools in 1991?
Your answer should be compact. -49.81. What is the difference between the Gross enrolment ratio (%) of Pre-primary schools in 1990 and the Gross enrolment ratio (%) of Secondary schools in 1991?
Provide a short and direct response. -37.94. What is the difference between the Gross enrolment ratio (%) of Pre-primary schools in 1990 and the Gross enrolment ratio (%) of Tertiary schools in 1991?
Provide a short and direct response. 4.18. What is the difference between the Gross enrolment ratio (%) of Primary schools in 1990 and the Gross enrolment ratio (%) of Secondary schools in 1991?
Your response must be concise. 11.59. What is the difference between the Gross enrolment ratio (%) in Primary schools in 1990 and the Gross enrolment ratio (%) in Tertiary schools in 1991?
Provide a succinct answer. 53.7. What is the difference between the Gross enrolment ratio (%) of Secondary schools in 1990 and the Gross enrolment ratio (%) of Tertiary schools in 1991?
Give a very brief answer. 43.1. What is the difference between the Gross enrolment ratio (%) of Pre-primary schools in 1990 and the Gross enrolment ratio (%) of Primary schools in 1992?
Make the answer very short. -49.53. What is the difference between the Gross enrolment ratio (%) of Pre-primary schools in 1990 and the Gross enrolment ratio (%) of Secondary schools in 1992?
Offer a terse response. -37.61. What is the difference between the Gross enrolment ratio (%) of Pre-primary schools in 1990 and the Gross enrolment ratio (%) of Tertiary schools in 1992?
Offer a very short reply. 1.45. What is the difference between the Gross enrolment ratio (%) in Primary schools in 1990 and the Gross enrolment ratio (%) in Secondary schools in 1992?
Make the answer very short. 11.92. What is the difference between the Gross enrolment ratio (%) of Primary schools in 1990 and the Gross enrolment ratio (%) of Tertiary schools in 1992?
Provide a succinct answer. 50.98. What is the difference between the Gross enrolment ratio (%) in Secondary schools in 1990 and the Gross enrolment ratio (%) in Tertiary schools in 1992?
Your response must be concise. 40.37. What is the difference between the Gross enrolment ratio (%) in Pre-primary schools in 1991 and the Gross enrolment ratio (%) in Primary schools in 1992?
Your answer should be compact. -46.77. What is the difference between the Gross enrolment ratio (%) in Pre-primary schools in 1991 and the Gross enrolment ratio (%) in Secondary schools in 1992?
Your response must be concise. -34.85. What is the difference between the Gross enrolment ratio (%) of Pre-primary schools in 1991 and the Gross enrolment ratio (%) of Tertiary schools in 1992?
Your response must be concise. 4.21. What is the difference between the Gross enrolment ratio (%) of Primary schools in 1991 and the Gross enrolment ratio (%) of Secondary schools in 1992?
Give a very brief answer. 12.2. What is the difference between the Gross enrolment ratio (%) of Primary schools in 1991 and the Gross enrolment ratio (%) of Tertiary schools in 1992?
Provide a succinct answer. 51.26. What is the difference between the Gross enrolment ratio (%) in Secondary schools in 1991 and the Gross enrolment ratio (%) in Tertiary schools in 1992?
Offer a very short reply. 39.38. What is the average Gross enrolment ratio (%) of Pre-primary schools per year?
Your response must be concise. 53.68. What is the average Gross enrolment ratio (%) of Primary schools per year?
Give a very brief answer. 103.55. What is the average Gross enrolment ratio (%) in Secondary schools per year?
Your answer should be very brief. 94.31. What is the average Gross enrolment ratio (%) in Tertiary schools per year?
Offer a very short reply. 50.12. In the year 1986, what is the difference between the Gross enrolment ratio (%) of Pre-primary schools and Gross enrolment ratio (%) of Primary schools?
Give a very brief answer. -57.56. In the year 1986, what is the difference between the Gross enrolment ratio (%) of Pre-primary schools and Gross enrolment ratio (%) of Secondary schools?
Provide a succinct answer. -50.8. In the year 1986, what is the difference between the Gross enrolment ratio (%) in Pre-primary schools and Gross enrolment ratio (%) in Tertiary schools?
Your answer should be very brief. -4.77. In the year 1986, what is the difference between the Gross enrolment ratio (%) in Primary schools and Gross enrolment ratio (%) in Secondary schools?
Offer a very short reply. 6.76. In the year 1986, what is the difference between the Gross enrolment ratio (%) in Primary schools and Gross enrolment ratio (%) in Tertiary schools?
Keep it short and to the point. 52.79. In the year 1986, what is the difference between the Gross enrolment ratio (%) in Secondary schools and Gross enrolment ratio (%) in Tertiary schools?
Make the answer very short. 46.03. In the year 1987, what is the difference between the Gross enrolment ratio (%) in Pre-primary schools and Gross enrolment ratio (%) in Primary schools?
Offer a very short reply. -53.5. In the year 1987, what is the difference between the Gross enrolment ratio (%) in Pre-primary schools and Gross enrolment ratio (%) in Secondary schools?
Keep it short and to the point. -46.62. In the year 1987, what is the difference between the Gross enrolment ratio (%) of Pre-primary schools and Gross enrolment ratio (%) of Tertiary schools?
Give a very brief answer. -0.36. In the year 1987, what is the difference between the Gross enrolment ratio (%) of Primary schools and Gross enrolment ratio (%) of Secondary schools?
Ensure brevity in your answer.  6.88. In the year 1987, what is the difference between the Gross enrolment ratio (%) of Primary schools and Gross enrolment ratio (%) of Tertiary schools?
Keep it short and to the point. 53.14. In the year 1987, what is the difference between the Gross enrolment ratio (%) in Secondary schools and Gross enrolment ratio (%) in Tertiary schools?
Offer a terse response. 46.26. In the year 1988, what is the difference between the Gross enrolment ratio (%) of Pre-primary schools and Gross enrolment ratio (%) of Primary schools?
Offer a terse response. -48.93. In the year 1988, what is the difference between the Gross enrolment ratio (%) in Pre-primary schools and Gross enrolment ratio (%) in Secondary schools?
Offer a very short reply. -41.19. In the year 1988, what is the difference between the Gross enrolment ratio (%) in Pre-primary schools and Gross enrolment ratio (%) in Tertiary schools?
Offer a very short reply. 4.87. In the year 1988, what is the difference between the Gross enrolment ratio (%) in Primary schools and Gross enrolment ratio (%) in Secondary schools?
Your response must be concise. 7.74. In the year 1988, what is the difference between the Gross enrolment ratio (%) in Primary schools and Gross enrolment ratio (%) in Tertiary schools?
Offer a very short reply. 53.8. In the year 1988, what is the difference between the Gross enrolment ratio (%) in Secondary schools and Gross enrolment ratio (%) in Tertiary schools?
Make the answer very short. 46.06. In the year 1989, what is the difference between the Gross enrolment ratio (%) in Pre-primary schools and Gross enrolment ratio (%) in Primary schools?
Give a very brief answer. -49.87. In the year 1989, what is the difference between the Gross enrolment ratio (%) of Pre-primary schools and Gross enrolment ratio (%) of Secondary schools?
Provide a short and direct response. -40.99. In the year 1989, what is the difference between the Gross enrolment ratio (%) in Pre-primary schools and Gross enrolment ratio (%) in Tertiary schools?
Make the answer very short. 4.48. In the year 1989, what is the difference between the Gross enrolment ratio (%) in Primary schools and Gross enrolment ratio (%) in Secondary schools?
Ensure brevity in your answer.  8.88. In the year 1989, what is the difference between the Gross enrolment ratio (%) of Primary schools and Gross enrolment ratio (%) of Tertiary schools?
Offer a terse response. 54.35. In the year 1989, what is the difference between the Gross enrolment ratio (%) in Secondary schools and Gross enrolment ratio (%) in Tertiary schools?
Provide a short and direct response. 45.47. In the year 1990, what is the difference between the Gross enrolment ratio (%) of Pre-primary schools and Gross enrolment ratio (%) of Primary schools?
Offer a terse response. -49.53. In the year 1990, what is the difference between the Gross enrolment ratio (%) in Pre-primary schools and Gross enrolment ratio (%) in Secondary schools?
Keep it short and to the point. -38.92. In the year 1990, what is the difference between the Gross enrolment ratio (%) in Pre-primary schools and Gross enrolment ratio (%) in Tertiary schools?
Offer a terse response. 5.42. In the year 1990, what is the difference between the Gross enrolment ratio (%) of Primary schools and Gross enrolment ratio (%) of Secondary schools?
Your answer should be compact. 10.61. In the year 1990, what is the difference between the Gross enrolment ratio (%) of Primary schools and Gross enrolment ratio (%) of Tertiary schools?
Your answer should be very brief. 54.95. In the year 1990, what is the difference between the Gross enrolment ratio (%) in Secondary schools and Gross enrolment ratio (%) in Tertiary schools?
Make the answer very short. 44.35. In the year 1991, what is the difference between the Gross enrolment ratio (%) of Pre-primary schools and Gross enrolment ratio (%) of Primary schools?
Offer a very short reply. -47.05. In the year 1991, what is the difference between the Gross enrolment ratio (%) of Pre-primary schools and Gross enrolment ratio (%) of Secondary schools?
Your answer should be compact. -35.17. In the year 1991, what is the difference between the Gross enrolment ratio (%) of Pre-primary schools and Gross enrolment ratio (%) of Tertiary schools?
Your answer should be compact. 6.94. In the year 1991, what is the difference between the Gross enrolment ratio (%) in Primary schools and Gross enrolment ratio (%) in Secondary schools?
Ensure brevity in your answer.  11.88. In the year 1991, what is the difference between the Gross enrolment ratio (%) of Primary schools and Gross enrolment ratio (%) of Tertiary schools?
Keep it short and to the point. 53.99. In the year 1991, what is the difference between the Gross enrolment ratio (%) in Secondary schools and Gross enrolment ratio (%) in Tertiary schools?
Provide a succinct answer. 42.11. In the year 1992, what is the difference between the Gross enrolment ratio (%) in Pre-primary schools and Gross enrolment ratio (%) in Primary schools?
Give a very brief answer. -42.64. In the year 1992, what is the difference between the Gross enrolment ratio (%) in Pre-primary schools and Gross enrolment ratio (%) in Secondary schools?
Make the answer very short. -30.72. In the year 1992, what is the difference between the Gross enrolment ratio (%) of Pre-primary schools and Gross enrolment ratio (%) of Tertiary schools?
Your answer should be compact. 8.34. In the year 1992, what is the difference between the Gross enrolment ratio (%) of Primary schools and Gross enrolment ratio (%) of Secondary schools?
Provide a succinct answer. 11.92. In the year 1992, what is the difference between the Gross enrolment ratio (%) in Primary schools and Gross enrolment ratio (%) in Tertiary schools?
Give a very brief answer. 50.98. In the year 1992, what is the difference between the Gross enrolment ratio (%) of Secondary schools and Gross enrolment ratio (%) of Tertiary schools?
Provide a succinct answer. 39.06. What is the ratio of the Gross enrolment ratio (%) of Pre-primary schools in 1986 to that in 1987?
Provide a short and direct response. 0.9. What is the ratio of the Gross enrolment ratio (%) of Primary schools in 1986 to that in 1987?
Make the answer very short. 0.99. What is the ratio of the Gross enrolment ratio (%) of Pre-primary schools in 1986 to that in 1988?
Your answer should be compact. 0.81. What is the ratio of the Gross enrolment ratio (%) of Primary schools in 1986 to that in 1988?
Provide a succinct answer. 0.99. What is the ratio of the Gross enrolment ratio (%) in Tertiary schools in 1986 to that in 1988?
Your response must be concise. 0.99. What is the ratio of the Gross enrolment ratio (%) in Pre-primary schools in 1986 to that in 1989?
Your answer should be very brief. 0.8. What is the ratio of the Gross enrolment ratio (%) in Primary schools in 1986 to that in 1989?
Keep it short and to the point. 0.97. What is the ratio of the Gross enrolment ratio (%) in Tertiary schools in 1986 to that in 1989?
Give a very brief answer. 0.97. What is the ratio of the Gross enrolment ratio (%) in Pre-primary schools in 1986 to that in 1990?
Provide a succinct answer. 0.77. What is the ratio of the Gross enrolment ratio (%) in Primary schools in 1986 to that in 1990?
Give a very brief answer. 0.96. What is the ratio of the Gross enrolment ratio (%) in Tertiary schools in 1986 to that in 1990?
Your answer should be compact. 0.95. What is the ratio of the Gross enrolment ratio (%) of Pre-primary schools in 1986 to that in 1991?
Offer a very short reply. 0.74. What is the ratio of the Gross enrolment ratio (%) of Primary schools in 1986 to that in 1991?
Provide a short and direct response. 0.95. What is the ratio of the Gross enrolment ratio (%) in Tertiary schools in 1986 to that in 1991?
Offer a terse response. 0.93. What is the ratio of the Gross enrolment ratio (%) of Pre-primary schools in 1986 to that in 1992?
Provide a short and direct response. 0.69. What is the ratio of the Gross enrolment ratio (%) in Tertiary schools in 1986 to that in 1992?
Offer a terse response. 0.88. What is the ratio of the Gross enrolment ratio (%) of Pre-primary schools in 1987 to that in 1988?
Offer a very short reply. 0.9. What is the ratio of the Gross enrolment ratio (%) in Primary schools in 1987 to that in 1988?
Make the answer very short. 0.99. What is the ratio of the Gross enrolment ratio (%) of Pre-primary schools in 1987 to that in 1989?
Keep it short and to the point. 0.9. What is the ratio of the Gross enrolment ratio (%) of Primary schools in 1987 to that in 1989?
Your answer should be very brief. 0.98. What is the ratio of the Gross enrolment ratio (%) in Tertiary schools in 1987 to that in 1989?
Give a very brief answer. 0.98. What is the ratio of the Gross enrolment ratio (%) of Pre-primary schools in 1987 to that in 1990?
Your answer should be very brief. 0.86. What is the ratio of the Gross enrolment ratio (%) of Primary schools in 1987 to that in 1990?
Keep it short and to the point. 0.97. What is the ratio of the Gross enrolment ratio (%) in Secondary schools in 1987 to that in 1990?
Your response must be concise. 1. What is the ratio of the Gross enrolment ratio (%) in Tertiary schools in 1987 to that in 1990?
Provide a short and direct response. 0.96. What is the ratio of the Gross enrolment ratio (%) in Pre-primary schools in 1987 to that in 1991?
Offer a terse response. 0.82. What is the ratio of the Gross enrolment ratio (%) in Primary schools in 1987 to that in 1991?
Provide a succinct answer. 0.96. What is the ratio of the Gross enrolment ratio (%) in Secondary schools in 1987 to that in 1991?
Your answer should be compact. 1.01. What is the ratio of the Gross enrolment ratio (%) of Tertiary schools in 1987 to that in 1991?
Give a very brief answer. 0.94. What is the ratio of the Gross enrolment ratio (%) of Pre-primary schools in 1987 to that in 1992?
Offer a very short reply. 0.77. What is the ratio of the Gross enrolment ratio (%) in Primary schools in 1987 to that in 1992?
Make the answer very short. 0.97. What is the ratio of the Gross enrolment ratio (%) of Secondary schools in 1987 to that in 1992?
Your response must be concise. 1.01. What is the ratio of the Gross enrolment ratio (%) of Tertiary schools in 1987 to that in 1992?
Ensure brevity in your answer.  0.89. What is the ratio of the Gross enrolment ratio (%) in Pre-primary schools in 1988 to that in 1989?
Keep it short and to the point. 0.99. What is the ratio of the Gross enrolment ratio (%) in Primary schools in 1988 to that in 1989?
Your answer should be compact. 0.99. What is the ratio of the Gross enrolment ratio (%) in Secondary schools in 1988 to that in 1989?
Your answer should be very brief. 1. What is the ratio of the Gross enrolment ratio (%) of Tertiary schools in 1988 to that in 1989?
Your answer should be compact. 0.98. What is the ratio of the Gross enrolment ratio (%) of Pre-primary schools in 1988 to that in 1990?
Your response must be concise. 0.96. What is the ratio of the Gross enrolment ratio (%) in Primary schools in 1988 to that in 1990?
Keep it short and to the point. 0.97. What is the ratio of the Gross enrolment ratio (%) in Tertiary schools in 1988 to that in 1990?
Provide a succinct answer. 0.96. What is the ratio of the Gross enrolment ratio (%) in Pre-primary schools in 1988 to that in 1991?
Your answer should be compact. 0.91. What is the ratio of the Gross enrolment ratio (%) in Primary schools in 1988 to that in 1991?
Your answer should be compact. 0.97. What is the ratio of the Gross enrolment ratio (%) in Secondary schools in 1988 to that in 1991?
Provide a short and direct response. 1.01. What is the ratio of the Gross enrolment ratio (%) in Tertiary schools in 1988 to that in 1991?
Ensure brevity in your answer.  0.94. What is the ratio of the Gross enrolment ratio (%) in Pre-primary schools in 1988 to that in 1992?
Provide a succinct answer. 0.85. What is the ratio of the Gross enrolment ratio (%) in Primary schools in 1988 to that in 1992?
Keep it short and to the point. 0.97. What is the ratio of the Gross enrolment ratio (%) of Secondary schools in 1988 to that in 1992?
Provide a succinct answer. 1.01. What is the ratio of the Gross enrolment ratio (%) in Tertiary schools in 1988 to that in 1992?
Keep it short and to the point. 0.89. What is the ratio of the Gross enrolment ratio (%) in Pre-primary schools in 1989 to that in 1990?
Provide a succinct answer. 0.96. What is the ratio of the Gross enrolment ratio (%) of Primary schools in 1989 to that in 1990?
Keep it short and to the point. 0.98. What is the ratio of the Gross enrolment ratio (%) of Secondary schools in 1989 to that in 1990?
Your answer should be compact. 1. What is the ratio of the Gross enrolment ratio (%) of Tertiary schools in 1989 to that in 1990?
Ensure brevity in your answer.  0.98. What is the ratio of the Gross enrolment ratio (%) of Pre-primary schools in 1989 to that in 1991?
Offer a terse response. 0.92. What is the ratio of the Gross enrolment ratio (%) in Primary schools in 1989 to that in 1991?
Give a very brief answer. 0.98. What is the ratio of the Gross enrolment ratio (%) of Secondary schools in 1989 to that in 1991?
Ensure brevity in your answer.  1.01. What is the ratio of the Gross enrolment ratio (%) of Tertiary schools in 1989 to that in 1991?
Your response must be concise. 0.96. What is the ratio of the Gross enrolment ratio (%) of Pre-primary schools in 1989 to that in 1992?
Give a very brief answer. 0.86. What is the ratio of the Gross enrolment ratio (%) of Primary schools in 1989 to that in 1992?
Make the answer very short. 0.98. What is the ratio of the Gross enrolment ratio (%) in Secondary schools in 1989 to that in 1992?
Keep it short and to the point. 1.01. What is the ratio of the Gross enrolment ratio (%) of Tertiary schools in 1989 to that in 1992?
Offer a terse response. 0.91. What is the ratio of the Gross enrolment ratio (%) of Pre-primary schools in 1990 to that in 1991?
Provide a short and direct response. 0.95. What is the ratio of the Gross enrolment ratio (%) in Primary schools in 1990 to that in 1991?
Give a very brief answer. 1. What is the ratio of the Gross enrolment ratio (%) in Secondary schools in 1990 to that in 1991?
Your answer should be compact. 1.01. What is the ratio of the Gross enrolment ratio (%) of Tertiary schools in 1990 to that in 1991?
Your answer should be very brief. 0.98. What is the ratio of the Gross enrolment ratio (%) of Pre-primary schools in 1990 to that in 1992?
Provide a succinct answer. 0.89. What is the ratio of the Gross enrolment ratio (%) of Primary schools in 1990 to that in 1992?
Provide a short and direct response. 1. What is the ratio of the Gross enrolment ratio (%) in Tertiary schools in 1990 to that in 1992?
Keep it short and to the point. 0.93. What is the ratio of the Gross enrolment ratio (%) of Pre-primary schools in 1991 to that in 1992?
Your response must be concise. 0.93. What is the ratio of the Gross enrolment ratio (%) of Primary schools in 1991 to that in 1992?
Your answer should be compact. 1. What is the ratio of the Gross enrolment ratio (%) of Tertiary schools in 1991 to that in 1992?
Give a very brief answer. 0.95. What is the difference between the highest and the second highest Gross enrolment ratio (%) of Pre-primary schools?
Your response must be concise. 4.13. What is the difference between the highest and the second highest Gross enrolment ratio (%) in Primary schools?
Offer a very short reply. 0.28. What is the difference between the highest and the second highest Gross enrolment ratio (%) in Secondary schools?
Your answer should be compact. 0. What is the difference between the highest and the second highest Gross enrolment ratio (%) in Tertiary schools?
Make the answer very short. 2.73. What is the difference between the highest and the lowest Gross enrolment ratio (%) of Pre-primary schools?
Offer a terse response. 19.46. What is the difference between the highest and the lowest Gross enrolment ratio (%) in Primary schools?
Provide a succinct answer. 4.81. What is the difference between the highest and the lowest Gross enrolment ratio (%) in Secondary schools?
Provide a succinct answer. 1.4. What is the difference between the highest and the lowest Gross enrolment ratio (%) in Tertiary schools?
Your answer should be compact. 6.34. 